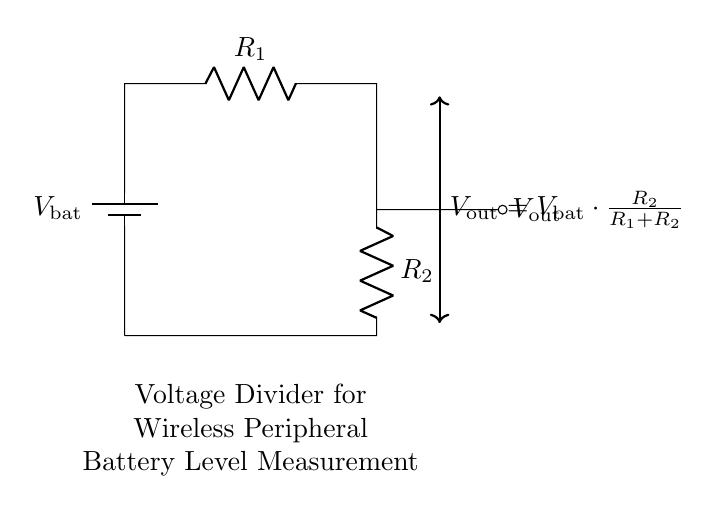What is the voltage source in this circuit? The voltage source in the circuit is represented by the battery symbol, labeled as V bat. It provides the input voltage for the circuit.
Answer: V bat What are the resistors in the voltage divider? The resistors in the voltage divider are labeled R 1 and R 2. They are connected in series, forming the voltage divider configuration.
Answer: R 1 and R 2 What is the output voltage formula stated in the diagram? The output voltage formula given in the diagram is written beside the indicated output node as V out equals V bat times R 2 over R 1 plus R 2. This is the fundamental equation for a voltage divider.
Answer: V out = V bat * R 2 / (R 1 + R 2) How does R 2 affect the output voltage? R 2's value directly influences the output voltage. Increasing R 2 will increase V out, while decreasing R 2 will decrease V out, according to the voltage divider formula.
Answer: It increases V out What will happen if R 1 is much larger than R 2? If R 1 is much larger than R 2, the output voltage V out will be much smaller, approaching zero as R 1 increases significantly compared to R 2, indicating that most of the voltage drops across R 1.
Answer: V out approaches zero What is the purpose of this circuit? The purpose of the circuit is to measure the battery level of wireless peripherals like keyboards and mice by providing a scaled down voltage output that can be read by a microcontroller.
Answer: Battery level measurement What type of circuit is this? This is a voltage divider circuit specifically designed for measuring voltage levels. It divides the input voltage into a smaller, manageable output voltage.
Answer: Voltage divider circuit 